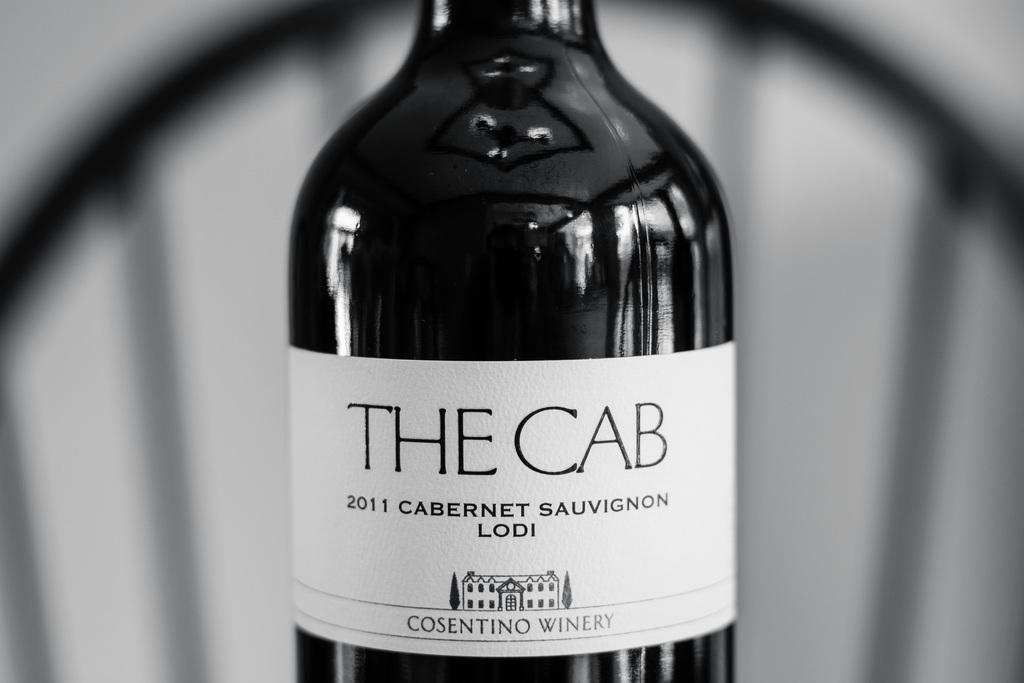<image>
Write a terse but informative summary of the picture. A bottle of 2011 cabernet sauvignon from the Consentino Winery. 